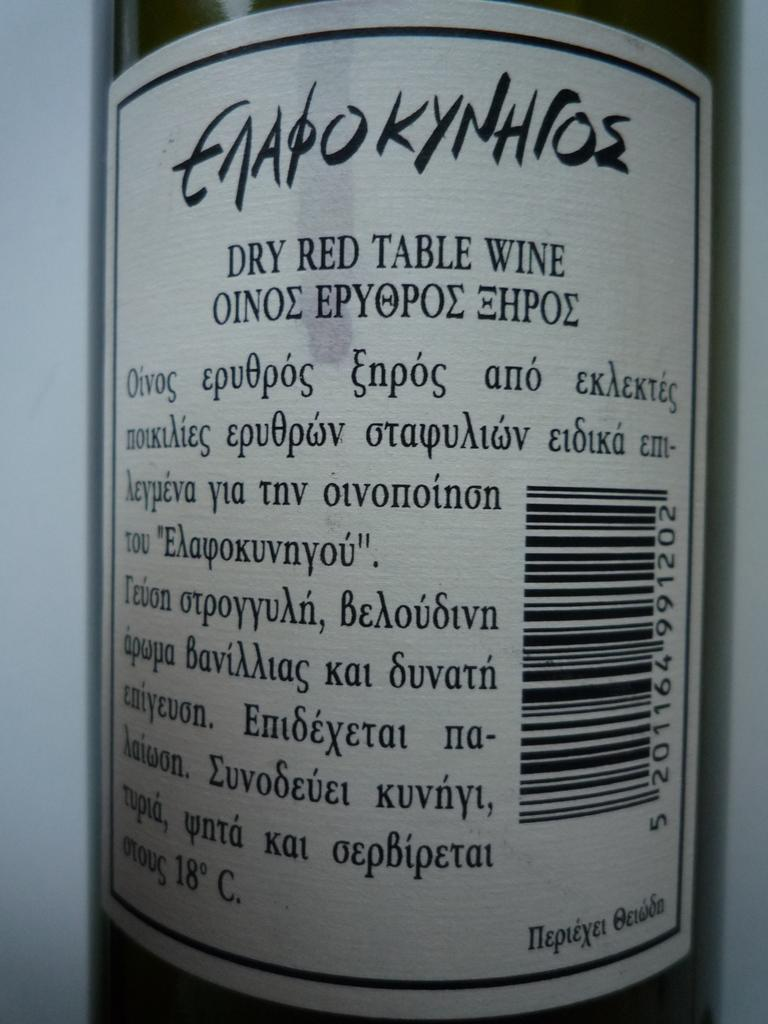<image>
Summarize the visual content of the image. The label on the back of a bottle of Enapokynhios is classified as a dry, red, table wine. 